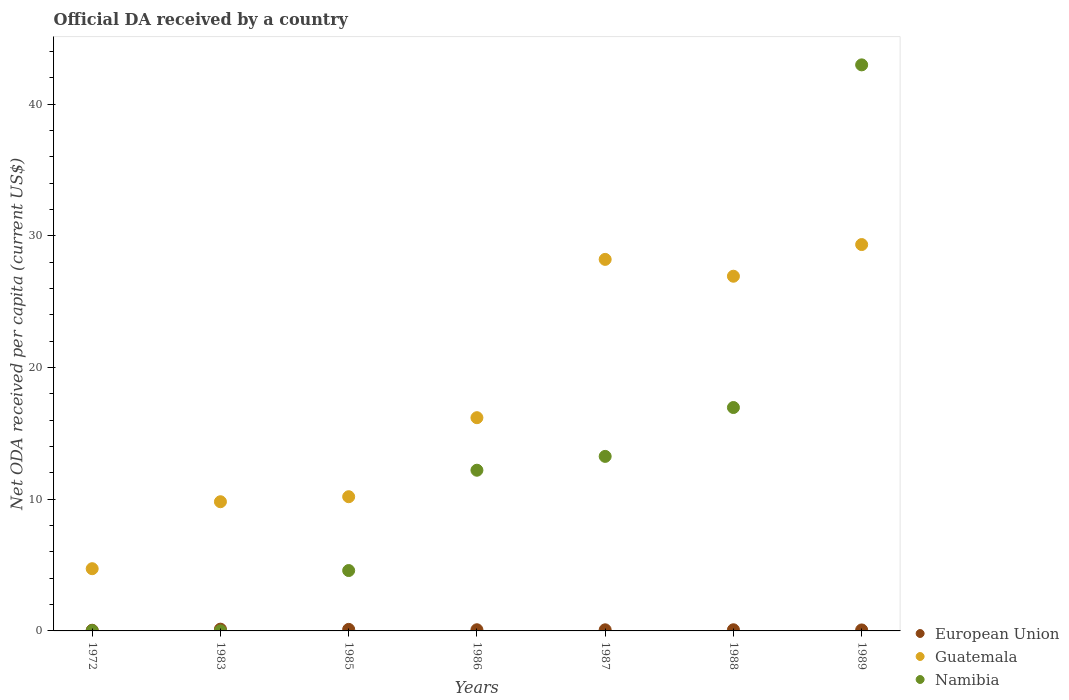How many different coloured dotlines are there?
Your answer should be compact. 3. Is the number of dotlines equal to the number of legend labels?
Offer a very short reply. Yes. What is the ODA received in in Guatemala in 1989?
Your answer should be very brief. 29.34. Across all years, what is the maximum ODA received in in Namibia?
Ensure brevity in your answer.  42.99. Across all years, what is the minimum ODA received in in Namibia?
Keep it short and to the point. 0.01. In which year was the ODA received in in Namibia minimum?
Your response must be concise. 1983. What is the total ODA received in in Namibia in the graph?
Offer a very short reply. 90.03. What is the difference between the ODA received in in Guatemala in 1985 and that in 1988?
Make the answer very short. -16.74. What is the difference between the ODA received in in European Union in 1986 and the ODA received in in Guatemala in 1987?
Offer a terse response. -28.13. What is the average ODA received in in Namibia per year?
Offer a terse response. 12.86. In the year 1985, what is the difference between the ODA received in in Guatemala and ODA received in in European Union?
Your answer should be very brief. 10.07. What is the ratio of the ODA received in in Guatemala in 1986 to that in 1989?
Your answer should be compact. 0.55. Is the ODA received in in Namibia in 1986 less than that in 1988?
Ensure brevity in your answer.  Yes. What is the difference between the highest and the second highest ODA received in in Guatemala?
Offer a very short reply. 1.13. What is the difference between the highest and the lowest ODA received in in Namibia?
Provide a succinct answer. 42.98. In how many years, is the ODA received in in European Union greater than the average ODA received in in European Union taken over all years?
Ensure brevity in your answer.  2. Is the sum of the ODA received in in Guatemala in 1986 and 1989 greater than the maximum ODA received in in Namibia across all years?
Make the answer very short. Yes. Does the ODA received in in Guatemala monotonically increase over the years?
Your answer should be compact. No. Is the ODA received in in Guatemala strictly greater than the ODA received in in Namibia over the years?
Provide a short and direct response. No. What is the difference between two consecutive major ticks on the Y-axis?
Give a very brief answer. 10. How are the legend labels stacked?
Provide a succinct answer. Vertical. What is the title of the graph?
Your answer should be compact. Official DA received by a country. What is the label or title of the Y-axis?
Ensure brevity in your answer.  Net ODA received per capita (current US$). What is the Net ODA received per capita (current US$) of European Union in 1972?
Keep it short and to the point. 0.05. What is the Net ODA received per capita (current US$) of Guatemala in 1972?
Provide a short and direct response. 4.72. What is the Net ODA received per capita (current US$) in Namibia in 1972?
Offer a terse response. 0.02. What is the Net ODA received per capita (current US$) in European Union in 1983?
Provide a short and direct response. 0.13. What is the Net ODA received per capita (current US$) in Guatemala in 1983?
Make the answer very short. 9.81. What is the Net ODA received per capita (current US$) in Namibia in 1983?
Your answer should be very brief. 0.01. What is the Net ODA received per capita (current US$) of European Union in 1985?
Your answer should be very brief. 0.12. What is the Net ODA received per capita (current US$) of Guatemala in 1985?
Your response must be concise. 10.19. What is the Net ODA received per capita (current US$) in Namibia in 1985?
Offer a terse response. 4.59. What is the Net ODA received per capita (current US$) in European Union in 1986?
Your answer should be very brief. 0.09. What is the Net ODA received per capita (current US$) of Guatemala in 1986?
Your answer should be compact. 16.19. What is the Net ODA received per capita (current US$) of Namibia in 1986?
Offer a very short reply. 12.2. What is the Net ODA received per capita (current US$) in European Union in 1987?
Offer a terse response. 0.08. What is the Net ODA received per capita (current US$) of Guatemala in 1987?
Your response must be concise. 28.21. What is the Net ODA received per capita (current US$) in Namibia in 1987?
Give a very brief answer. 13.25. What is the Net ODA received per capita (current US$) in European Union in 1988?
Make the answer very short. 0.09. What is the Net ODA received per capita (current US$) of Guatemala in 1988?
Keep it short and to the point. 26.94. What is the Net ODA received per capita (current US$) of Namibia in 1988?
Your answer should be very brief. 16.96. What is the Net ODA received per capita (current US$) of European Union in 1989?
Make the answer very short. 0.07. What is the Net ODA received per capita (current US$) in Guatemala in 1989?
Your response must be concise. 29.34. What is the Net ODA received per capita (current US$) in Namibia in 1989?
Your answer should be very brief. 42.99. Across all years, what is the maximum Net ODA received per capita (current US$) of European Union?
Ensure brevity in your answer.  0.13. Across all years, what is the maximum Net ODA received per capita (current US$) of Guatemala?
Ensure brevity in your answer.  29.34. Across all years, what is the maximum Net ODA received per capita (current US$) in Namibia?
Offer a terse response. 42.99. Across all years, what is the minimum Net ODA received per capita (current US$) of European Union?
Provide a succinct answer. 0.05. Across all years, what is the minimum Net ODA received per capita (current US$) in Guatemala?
Make the answer very short. 4.72. Across all years, what is the minimum Net ODA received per capita (current US$) in Namibia?
Offer a very short reply. 0.01. What is the total Net ODA received per capita (current US$) in European Union in the graph?
Your answer should be compact. 0.64. What is the total Net ODA received per capita (current US$) in Guatemala in the graph?
Your response must be concise. 125.41. What is the total Net ODA received per capita (current US$) of Namibia in the graph?
Your answer should be compact. 90.03. What is the difference between the Net ODA received per capita (current US$) in European Union in 1972 and that in 1983?
Provide a short and direct response. -0.08. What is the difference between the Net ODA received per capita (current US$) in Guatemala in 1972 and that in 1983?
Your response must be concise. -5.09. What is the difference between the Net ODA received per capita (current US$) in Namibia in 1972 and that in 1983?
Make the answer very short. 0.01. What is the difference between the Net ODA received per capita (current US$) in European Union in 1972 and that in 1985?
Offer a very short reply. -0.07. What is the difference between the Net ODA received per capita (current US$) in Guatemala in 1972 and that in 1985?
Make the answer very short. -5.47. What is the difference between the Net ODA received per capita (current US$) of Namibia in 1972 and that in 1985?
Make the answer very short. -4.56. What is the difference between the Net ODA received per capita (current US$) in European Union in 1972 and that in 1986?
Make the answer very short. -0.04. What is the difference between the Net ODA received per capita (current US$) of Guatemala in 1972 and that in 1986?
Make the answer very short. -11.47. What is the difference between the Net ODA received per capita (current US$) in Namibia in 1972 and that in 1986?
Make the answer very short. -12.18. What is the difference between the Net ODA received per capita (current US$) in European Union in 1972 and that in 1987?
Keep it short and to the point. -0.03. What is the difference between the Net ODA received per capita (current US$) of Guatemala in 1972 and that in 1987?
Offer a terse response. -23.49. What is the difference between the Net ODA received per capita (current US$) in Namibia in 1972 and that in 1987?
Provide a short and direct response. -13.23. What is the difference between the Net ODA received per capita (current US$) of European Union in 1972 and that in 1988?
Make the answer very short. -0.04. What is the difference between the Net ODA received per capita (current US$) in Guatemala in 1972 and that in 1988?
Your answer should be compact. -22.21. What is the difference between the Net ODA received per capita (current US$) of Namibia in 1972 and that in 1988?
Provide a succinct answer. -16.94. What is the difference between the Net ODA received per capita (current US$) of European Union in 1972 and that in 1989?
Keep it short and to the point. -0.02. What is the difference between the Net ODA received per capita (current US$) in Guatemala in 1972 and that in 1989?
Your response must be concise. -24.62. What is the difference between the Net ODA received per capita (current US$) in Namibia in 1972 and that in 1989?
Your answer should be compact. -42.96. What is the difference between the Net ODA received per capita (current US$) in European Union in 1983 and that in 1985?
Keep it short and to the point. 0.02. What is the difference between the Net ODA received per capita (current US$) of Guatemala in 1983 and that in 1985?
Keep it short and to the point. -0.38. What is the difference between the Net ODA received per capita (current US$) in Namibia in 1983 and that in 1985?
Your response must be concise. -4.58. What is the difference between the Net ODA received per capita (current US$) of European Union in 1983 and that in 1986?
Offer a very short reply. 0.04. What is the difference between the Net ODA received per capita (current US$) of Guatemala in 1983 and that in 1986?
Offer a very short reply. -6.38. What is the difference between the Net ODA received per capita (current US$) of Namibia in 1983 and that in 1986?
Keep it short and to the point. -12.19. What is the difference between the Net ODA received per capita (current US$) in European Union in 1983 and that in 1987?
Offer a terse response. 0.05. What is the difference between the Net ODA received per capita (current US$) of Guatemala in 1983 and that in 1987?
Provide a short and direct response. -18.4. What is the difference between the Net ODA received per capita (current US$) of Namibia in 1983 and that in 1987?
Your answer should be compact. -13.24. What is the difference between the Net ODA received per capita (current US$) of European Union in 1983 and that in 1988?
Provide a short and direct response. 0.05. What is the difference between the Net ODA received per capita (current US$) of Guatemala in 1983 and that in 1988?
Ensure brevity in your answer.  -17.12. What is the difference between the Net ODA received per capita (current US$) of Namibia in 1983 and that in 1988?
Keep it short and to the point. -16.96. What is the difference between the Net ODA received per capita (current US$) of European Union in 1983 and that in 1989?
Your answer should be very brief. 0.06. What is the difference between the Net ODA received per capita (current US$) of Guatemala in 1983 and that in 1989?
Offer a terse response. -19.53. What is the difference between the Net ODA received per capita (current US$) in Namibia in 1983 and that in 1989?
Your answer should be very brief. -42.98. What is the difference between the Net ODA received per capita (current US$) in European Union in 1985 and that in 1986?
Offer a terse response. 0.03. What is the difference between the Net ODA received per capita (current US$) in Guatemala in 1985 and that in 1986?
Your answer should be very brief. -6. What is the difference between the Net ODA received per capita (current US$) in Namibia in 1985 and that in 1986?
Make the answer very short. -7.62. What is the difference between the Net ODA received per capita (current US$) in European Union in 1985 and that in 1987?
Provide a short and direct response. 0.03. What is the difference between the Net ODA received per capita (current US$) of Guatemala in 1985 and that in 1987?
Ensure brevity in your answer.  -18.02. What is the difference between the Net ODA received per capita (current US$) of Namibia in 1985 and that in 1987?
Provide a short and direct response. -8.67. What is the difference between the Net ODA received per capita (current US$) of European Union in 1985 and that in 1988?
Your answer should be compact. 0.03. What is the difference between the Net ODA received per capita (current US$) in Guatemala in 1985 and that in 1988?
Provide a short and direct response. -16.74. What is the difference between the Net ODA received per capita (current US$) in Namibia in 1985 and that in 1988?
Keep it short and to the point. -12.38. What is the difference between the Net ODA received per capita (current US$) in European Union in 1985 and that in 1989?
Your answer should be compact. 0.04. What is the difference between the Net ODA received per capita (current US$) of Guatemala in 1985 and that in 1989?
Offer a very short reply. -19.15. What is the difference between the Net ODA received per capita (current US$) of Namibia in 1985 and that in 1989?
Make the answer very short. -38.4. What is the difference between the Net ODA received per capita (current US$) in European Union in 1986 and that in 1987?
Offer a terse response. 0. What is the difference between the Net ODA received per capita (current US$) of Guatemala in 1986 and that in 1987?
Offer a terse response. -12.02. What is the difference between the Net ODA received per capita (current US$) in Namibia in 1986 and that in 1987?
Keep it short and to the point. -1.05. What is the difference between the Net ODA received per capita (current US$) of European Union in 1986 and that in 1988?
Provide a short and direct response. 0. What is the difference between the Net ODA received per capita (current US$) in Guatemala in 1986 and that in 1988?
Offer a terse response. -10.74. What is the difference between the Net ODA received per capita (current US$) in Namibia in 1986 and that in 1988?
Your answer should be very brief. -4.76. What is the difference between the Net ODA received per capita (current US$) in European Union in 1986 and that in 1989?
Your answer should be very brief. 0.01. What is the difference between the Net ODA received per capita (current US$) in Guatemala in 1986 and that in 1989?
Your response must be concise. -13.15. What is the difference between the Net ODA received per capita (current US$) in Namibia in 1986 and that in 1989?
Provide a short and direct response. -30.78. What is the difference between the Net ODA received per capita (current US$) in European Union in 1987 and that in 1988?
Your answer should be compact. -0. What is the difference between the Net ODA received per capita (current US$) of Guatemala in 1987 and that in 1988?
Your response must be concise. 1.28. What is the difference between the Net ODA received per capita (current US$) in Namibia in 1987 and that in 1988?
Your response must be concise. -3.71. What is the difference between the Net ODA received per capita (current US$) of European Union in 1987 and that in 1989?
Ensure brevity in your answer.  0.01. What is the difference between the Net ODA received per capita (current US$) in Guatemala in 1987 and that in 1989?
Provide a short and direct response. -1.13. What is the difference between the Net ODA received per capita (current US$) in Namibia in 1987 and that in 1989?
Your answer should be very brief. -29.73. What is the difference between the Net ODA received per capita (current US$) in European Union in 1988 and that in 1989?
Keep it short and to the point. 0.01. What is the difference between the Net ODA received per capita (current US$) of Guatemala in 1988 and that in 1989?
Make the answer very short. -2.4. What is the difference between the Net ODA received per capita (current US$) of Namibia in 1988 and that in 1989?
Your answer should be very brief. -26.02. What is the difference between the Net ODA received per capita (current US$) in European Union in 1972 and the Net ODA received per capita (current US$) in Guatemala in 1983?
Your answer should be compact. -9.76. What is the difference between the Net ODA received per capita (current US$) in European Union in 1972 and the Net ODA received per capita (current US$) in Namibia in 1983?
Provide a succinct answer. 0.04. What is the difference between the Net ODA received per capita (current US$) in Guatemala in 1972 and the Net ODA received per capita (current US$) in Namibia in 1983?
Provide a short and direct response. 4.72. What is the difference between the Net ODA received per capita (current US$) of European Union in 1972 and the Net ODA received per capita (current US$) of Guatemala in 1985?
Provide a succinct answer. -10.14. What is the difference between the Net ODA received per capita (current US$) of European Union in 1972 and the Net ODA received per capita (current US$) of Namibia in 1985?
Your answer should be very brief. -4.54. What is the difference between the Net ODA received per capita (current US$) in Guatemala in 1972 and the Net ODA received per capita (current US$) in Namibia in 1985?
Give a very brief answer. 0.14. What is the difference between the Net ODA received per capita (current US$) of European Union in 1972 and the Net ODA received per capita (current US$) of Guatemala in 1986?
Provide a short and direct response. -16.14. What is the difference between the Net ODA received per capita (current US$) in European Union in 1972 and the Net ODA received per capita (current US$) in Namibia in 1986?
Provide a succinct answer. -12.15. What is the difference between the Net ODA received per capita (current US$) in Guatemala in 1972 and the Net ODA received per capita (current US$) in Namibia in 1986?
Ensure brevity in your answer.  -7.48. What is the difference between the Net ODA received per capita (current US$) of European Union in 1972 and the Net ODA received per capita (current US$) of Guatemala in 1987?
Your answer should be very brief. -28.16. What is the difference between the Net ODA received per capita (current US$) of European Union in 1972 and the Net ODA received per capita (current US$) of Namibia in 1987?
Your answer should be very brief. -13.2. What is the difference between the Net ODA received per capita (current US$) in Guatemala in 1972 and the Net ODA received per capita (current US$) in Namibia in 1987?
Your answer should be compact. -8.53. What is the difference between the Net ODA received per capita (current US$) of European Union in 1972 and the Net ODA received per capita (current US$) of Guatemala in 1988?
Your answer should be compact. -26.89. What is the difference between the Net ODA received per capita (current US$) in European Union in 1972 and the Net ODA received per capita (current US$) in Namibia in 1988?
Offer a terse response. -16.91. What is the difference between the Net ODA received per capita (current US$) in Guatemala in 1972 and the Net ODA received per capita (current US$) in Namibia in 1988?
Provide a short and direct response. -12.24. What is the difference between the Net ODA received per capita (current US$) of European Union in 1972 and the Net ODA received per capita (current US$) of Guatemala in 1989?
Give a very brief answer. -29.29. What is the difference between the Net ODA received per capita (current US$) in European Union in 1972 and the Net ODA received per capita (current US$) in Namibia in 1989?
Make the answer very short. -42.94. What is the difference between the Net ODA received per capita (current US$) in Guatemala in 1972 and the Net ODA received per capita (current US$) in Namibia in 1989?
Keep it short and to the point. -38.26. What is the difference between the Net ODA received per capita (current US$) of European Union in 1983 and the Net ODA received per capita (current US$) of Guatemala in 1985?
Offer a terse response. -10.06. What is the difference between the Net ODA received per capita (current US$) in European Union in 1983 and the Net ODA received per capita (current US$) in Namibia in 1985?
Offer a terse response. -4.45. What is the difference between the Net ODA received per capita (current US$) in Guatemala in 1983 and the Net ODA received per capita (current US$) in Namibia in 1985?
Keep it short and to the point. 5.23. What is the difference between the Net ODA received per capita (current US$) of European Union in 1983 and the Net ODA received per capita (current US$) of Guatemala in 1986?
Your response must be concise. -16.06. What is the difference between the Net ODA received per capita (current US$) in European Union in 1983 and the Net ODA received per capita (current US$) in Namibia in 1986?
Your answer should be compact. -12.07. What is the difference between the Net ODA received per capita (current US$) in Guatemala in 1983 and the Net ODA received per capita (current US$) in Namibia in 1986?
Give a very brief answer. -2.39. What is the difference between the Net ODA received per capita (current US$) in European Union in 1983 and the Net ODA received per capita (current US$) in Guatemala in 1987?
Provide a short and direct response. -28.08. What is the difference between the Net ODA received per capita (current US$) in European Union in 1983 and the Net ODA received per capita (current US$) in Namibia in 1987?
Ensure brevity in your answer.  -13.12. What is the difference between the Net ODA received per capita (current US$) of Guatemala in 1983 and the Net ODA received per capita (current US$) of Namibia in 1987?
Provide a short and direct response. -3.44. What is the difference between the Net ODA received per capita (current US$) in European Union in 1983 and the Net ODA received per capita (current US$) in Guatemala in 1988?
Make the answer very short. -26.8. What is the difference between the Net ODA received per capita (current US$) in European Union in 1983 and the Net ODA received per capita (current US$) in Namibia in 1988?
Your answer should be compact. -16.83. What is the difference between the Net ODA received per capita (current US$) of Guatemala in 1983 and the Net ODA received per capita (current US$) of Namibia in 1988?
Keep it short and to the point. -7.15. What is the difference between the Net ODA received per capita (current US$) of European Union in 1983 and the Net ODA received per capita (current US$) of Guatemala in 1989?
Keep it short and to the point. -29.21. What is the difference between the Net ODA received per capita (current US$) in European Union in 1983 and the Net ODA received per capita (current US$) in Namibia in 1989?
Offer a terse response. -42.85. What is the difference between the Net ODA received per capita (current US$) in Guatemala in 1983 and the Net ODA received per capita (current US$) in Namibia in 1989?
Offer a terse response. -33.18. What is the difference between the Net ODA received per capita (current US$) of European Union in 1985 and the Net ODA received per capita (current US$) of Guatemala in 1986?
Offer a terse response. -16.08. What is the difference between the Net ODA received per capita (current US$) in European Union in 1985 and the Net ODA received per capita (current US$) in Namibia in 1986?
Provide a succinct answer. -12.09. What is the difference between the Net ODA received per capita (current US$) of Guatemala in 1985 and the Net ODA received per capita (current US$) of Namibia in 1986?
Provide a succinct answer. -2.01. What is the difference between the Net ODA received per capita (current US$) in European Union in 1985 and the Net ODA received per capita (current US$) in Guatemala in 1987?
Offer a terse response. -28.1. What is the difference between the Net ODA received per capita (current US$) in European Union in 1985 and the Net ODA received per capita (current US$) in Namibia in 1987?
Provide a succinct answer. -13.14. What is the difference between the Net ODA received per capita (current US$) of Guatemala in 1985 and the Net ODA received per capita (current US$) of Namibia in 1987?
Ensure brevity in your answer.  -3.06. What is the difference between the Net ODA received per capita (current US$) of European Union in 1985 and the Net ODA received per capita (current US$) of Guatemala in 1988?
Give a very brief answer. -26.82. What is the difference between the Net ODA received per capita (current US$) of European Union in 1985 and the Net ODA received per capita (current US$) of Namibia in 1988?
Give a very brief answer. -16.85. What is the difference between the Net ODA received per capita (current US$) of Guatemala in 1985 and the Net ODA received per capita (current US$) of Namibia in 1988?
Ensure brevity in your answer.  -6.77. What is the difference between the Net ODA received per capita (current US$) in European Union in 1985 and the Net ODA received per capita (current US$) in Guatemala in 1989?
Give a very brief answer. -29.22. What is the difference between the Net ODA received per capita (current US$) in European Union in 1985 and the Net ODA received per capita (current US$) in Namibia in 1989?
Offer a terse response. -42.87. What is the difference between the Net ODA received per capita (current US$) of Guatemala in 1985 and the Net ODA received per capita (current US$) of Namibia in 1989?
Offer a very short reply. -32.79. What is the difference between the Net ODA received per capita (current US$) in European Union in 1986 and the Net ODA received per capita (current US$) in Guatemala in 1987?
Make the answer very short. -28.13. What is the difference between the Net ODA received per capita (current US$) of European Union in 1986 and the Net ODA received per capita (current US$) of Namibia in 1987?
Provide a succinct answer. -13.17. What is the difference between the Net ODA received per capita (current US$) of Guatemala in 1986 and the Net ODA received per capita (current US$) of Namibia in 1987?
Provide a short and direct response. 2.94. What is the difference between the Net ODA received per capita (current US$) in European Union in 1986 and the Net ODA received per capita (current US$) in Guatemala in 1988?
Ensure brevity in your answer.  -26.85. What is the difference between the Net ODA received per capita (current US$) in European Union in 1986 and the Net ODA received per capita (current US$) in Namibia in 1988?
Provide a succinct answer. -16.88. What is the difference between the Net ODA received per capita (current US$) in Guatemala in 1986 and the Net ODA received per capita (current US$) in Namibia in 1988?
Offer a terse response. -0.77. What is the difference between the Net ODA received per capita (current US$) of European Union in 1986 and the Net ODA received per capita (current US$) of Guatemala in 1989?
Give a very brief answer. -29.25. What is the difference between the Net ODA received per capita (current US$) in European Union in 1986 and the Net ODA received per capita (current US$) in Namibia in 1989?
Your answer should be compact. -42.9. What is the difference between the Net ODA received per capita (current US$) of Guatemala in 1986 and the Net ODA received per capita (current US$) of Namibia in 1989?
Keep it short and to the point. -26.79. What is the difference between the Net ODA received per capita (current US$) of European Union in 1987 and the Net ODA received per capita (current US$) of Guatemala in 1988?
Provide a short and direct response. -26.85. What is the difference between the Net ODA received per capita (current US$) in European Union in 1987 and the Net ODA received per capita (current US$) in Namibia in 1988?
Ensure brevity in your answer.  -16.88. What is the difference between the Net ODA received per capita (current US$) of Guatemala in 1987 and the Net ODA received per capita (current US$) of Namibia in 1988?
Your answer should be very brief. 11.25. What is the difference between the Net ODA received per capita (current US$) in European Union in 1987 and the Net ODA received per capita (current US$) in Guatemala in 1989?
Provide a succinct answer. -29.26. What is the difference between the Net ODA received per capita (current US$) in European Union in 1987 and the Net ODA received per capita (current US$) in Namibia in 1989?
Provide a succinct answer. -42.9. What is the difference between the Net ODA received per capita (current US$) in Guatemala in 1987 and the Net ODA received per capita (current US$) in Namibia in 1989?
Provide a short and direct response. -14.77. What is the difference between the Net ODA received per capita (current US$) of European Union in 1988 and the Net ODA received per capita (current US$) of Guatemala in 1989?
Make the answer very short. -29.25. What is the difference between the Net ODA received per capita (current US$) in European Union in 1988 and the Net ODA received per capita (current US$) in Namibia in 1989?
Your answer should be very brief. -42.9. What is the difference between the Net ODA received per capita (current US$) of Guatemala in 1988 and the Net ODA received per capita (current US$) of Namibia in 1989?
Your response must be concise. -16.05. What is the average Net ODA received per capita (current US$) of European Union per year?
Your response must be concise. 0.09. What is the average Net ODA received per capita (current US$) of Guatemala per year?
Make the answer very short. 17.92. What is the average Net ODA received per capita (current US$) in Namibia per year?
Ensure brevity in your answer.  12.86. In the year 1972, what is the difference between the Net ODA received per capita (current US$) in European Union and Net ODA received per capita (current US$) in Guatemala?
Ensure brevity in your answer.  -4.67. In the year 1972, what is the difference between the Net ODA received per capita (current US$) in European Union and Net ODA received per capita (current US$) in Namibia?
Offer a terse response. 0.03. In the year 1972, what is the difference between the Net ODA received per capita (current US$) in Guatemala and Net ODA received per capita (current US$) in Namibia?
Provide a short and direct response. 4.7. In the year 1983, what is the difference between the Net ODA received per capita (current US$) of European Union and Net ODA received per capita (current US$) of Guatemala?
Offer a terse response. -9.68. In the year 1983, what is the difference between the Net ODA received per capita (current US$) of European Union and Net ODA received per capita (current US$) of Namibia?
Ensure brevity in your answer.  0.12. In the year 1983, what is the difference between the Net ODA received per capita (current US$) of Guatemala and Net ODA received per capita (current US$) of Namibia?
Offer a terse response. 9.8. In the year 1985, what is the difference between the Net ODA received per capita (current US$) of European Union and Net ODA received per capita (current US$) of Guatemala?
Make the answer very short. -10.07. In the year 1985, what is the difference between the Net ODA received per capita (current US$) in European Union and Net ODA received per capita (current US$) in Namibia?
Provide a succinct answer. -4.47. In the year 1985, what is the difference between the Net ODA received per capita (current US$) in Guatemala and Net ODA received per capita (current US$) in Namibia?
Give a very brief answer. 5.61. In the year 1986, what is the difference between the Net ODA received per capita (current US$) of European Union and Net ODA received per capita (current US$) of Guatemala?
Ensure brevity in your answer.  -16.1. In the year 1986, what is the difference between the Net ODA received per capita (current US$) in European Union and Net ODA received per capita (current US$) in Namibia?
Your answer should be compact. -12.11. In the year 1986, what is the difference between the Net ODA received per capita (current US$) in Guatemala and Net ODA received per capita (current US$) in Namibia?
Make the answer very short. 3.99. In the year 1987, what is the difference between the Net ODA received per capita (current US$) in European Union and Net ODA received per capita (current US$) in Guatemala?
Your response must be concise. -28.13. In the year 1987, what is the difference between the Net ODA received per capita (current US$) in European Union and Net ODA received per capita (current US$) in Namibia?
Ensure brevity in your answer.  -13.17. In the year 1987, what is the difference between the Net ODA received per capita (current US$) of Guatemala and Net ODA received per capita (current US$) of Namibia?
Ensure brevity in your answer.  14.96. In the year 1988, what is the difference between the Net ODA received per capita (current US$) in European Union and Net ODA received per capita (current US$) in Guatemala?
Make the answer very short. -26.85. In the year 1988, what is the difference between the Net ODA received per capita (current US$) of European Union and Net ODA received per capita (current US$) of Namibia?
Offer a terse response. -16.88. In the year 1988, what is the difference between the Net ODA received per capita (current US$) in Guatemala and Net ODA received per capita (current US$) in Namibia?
Keep it short and to the point. 9.97. In the year 1989, what is the difference between the Net ODA received per capita (current US$) of European Union and Net ODA received per capita (current US$) of Guatemala?
Make the answer very short. -29.27. In the year 1989, what is the difference between the Net ODA received per capita (current US$) of European Union and Net ODA received per capita (current US$) of Namibia?
Make the answer very short. -42.91. In the year 1989, what is the difference between the Net ODA received per capita (current US$) of Guatemala and Net ODA received per capita (current US$) of Namibia?
Your answer should be very brief. -13.65. What is the ratio of the Net ODA received per capita (current US$) of European Union in 1972 to that in 1983?
Give a very brief answer. 0.37. What is the ratio of the Net ODA received per capita (current US$) in Guatemala in 1972 to that in 1983?
Ensure brevity in your answer.  0.48. What is the ratio of the Net ODA received per capita (current US$) of Namibia in 1972 to that in 1983?
Offer a very short reply. 2.61. What is the ratio of the Net ODA received per capita (current US$) in European Union in 1972 to that in 1985?
Provide a succinct answer. 0.43. What is the ratio of the Net ODA received per capita (current US$) in Guatemala in 1972 to that in 1985?
Your answer should be very brief. 0.46. What is the ratio of the Net ODA received per capita (current US$) of Namibia in 1972 to that in 1985?
Make the answer very short. 0.01. What is the ratio of the Net ODA received per capita (current US$) in European Union in 1972 to that in 1986?
Your answer should be compact. 0.56. What is the ratio of the Net ODA received per capita (current US$) of Guatemala in 1972 to that in 1986?
Ensure brevity in your answer.  0.29. What is the ratio of the Net ODA received per capita (current US$) of Namibia in 1972 to that in 1986?
Give a very brief answer. 0. What is the ratio of the Net ODA received per capita (current US$) of European Union in 1972 to that in 1987?
Your answer should be compact. 0.59. What is the ratio of the Net ODA received per capita (current US$) in Guatemala in 1972 to that in 1987?
Offer a terse response. 0.17. What is the ratio of the Net ODA received per capita (current US$) in Namibia in 1972 to that in 1987?
Your answer should be compact. 0. What is the ratio of the Net ODA received per capita (current US$) of European Union in 1972 to that in 1988?
Make the answer very short. 0.57. What is the ratio of the Net ODA received per capita (current US$) of Guatemala in 1972 to that in 1988?
Give a very brief answer. 0.18. What is the ratio of the Net ODA received per capita (current US$) of Namibia in 1972 to that in 1988?
Your answer should be compact. 0. What is the ratio of the Net ODA received per capita (current US$) of European Union in 1972 to that in 1989?
Make the answer very short. 0.67. What is the ratio of the Net ODA received per capita (current US$) in Guatemala in 1972 to that in 1989?
Offer a terse response. 0.16. What is the ratio of the Net ODA received per capita (current US$) of Namibia in 1972 to that in 1989?
Provide a succinct answer. 0. What is the ratio of the Net ODA received per capita (current US$) of European Union in 1983 to that in 1985?
Offer a terse response. 1.14. What is the ratio of the Net ODA received per capita (current US$) in Guatemala in 1983 to that in 1985?
Provide a short and direct response. 0.96. What is the ratio of the Net ODA received per capita (current US$) in Namibia in 1983 to that in 1985?
Ensure brevity in your answer.  0. What is the ratio of the Net ODA received per capita (current US$) of European Union in 1983 to that in 1986?
Provide a succinct answer. 1.51. What is the ratio of the Net ODA received per capita (current US$) of Guatemala in 1983 to that in 1986?
Keep it short and to the point. 0.61. What is the ratio of the Net ODA received per capita (current US$) of Namibia in 1983 to that in 1986?
Provide a short and direct response. 0. What is the ratio of the Net ODA received per capita (current US$) of European Union in 1983 to that in 1987?
Your response must be concise. 1.59. What is the ratio of the Net ODA received per capita (current US$) in Guatemala in 1983 to that in 1987?
Offer a terse response. 0.35. What is the ratio of the Net ODA received per capita (current US$) in Namibia in 1983 to that in 1987?
Give a very brief answer. 0. What is the ratio of the Net ODA received per capita (current US$) in European Union in 1983 to that in 1988?
Ensure brevity in your answer.  1.53. What is the ratio of the Net ODA received per capita (current US$) in Guatemala in 1983 to that in 1988?
Keep it short and to the point. 0.36. What is the ratio of the Net ODA received per capita (current US$) in European Union in 1983 to that in 1989?
Provide a succinct answer. 1.79. What is the ratio of the Net ODA received per capita (current US$) in Guatemala in 1983 to that in 1989?
Provide a succinct answer. 0.33. What is the ratio of the Net ODA received per capita (current US$) of Namibia in 1983 to that in 1989?
Give a very brief answer. 0. What is the ratio of the Net ODA received per capita (current US$) in European Union in 1985 to that in 1986?
Ensure brevity in your answer.  1.32. What is the ratio of the Net ODA received per capita (current US$) in Guatemala in 1985 to that in 1986?
Offer a terse response. 0.63. What is the ratio of the Net ODA received per capita (current US$) in Namibia in 1985 to that in 1986?
Your answer should be very brief. 0.38. What is the ratio of the Net ODA received per capita (current US$) of European Union in 1985 to that in 1987?
Your answer should be compact. 1.39. What is the ratio of the Net ODA received per capita (current US$) of Guatemala in 1985 to that in 1987?
Give a very brief answer. 0.36. What is the ratio of the Net ODA received per capita (current US$) in Namibia in 1985 to that in 1987?
Provide a succinct answer. 0.35. What is the ratio of the Net ODA received per capita (current US$) in European Union in 1985 to that in 1988?
Offer a very short reply. 1.35. What is the ratio of the Net ODA received per capita (current US$) in Guatemala in 1985 to that in 1988?
Provide a short and direct response. 0.38. What is the ratio of the Net ODA received per capita (current US$) of Namibia in 1985 to that in 1988?
Make the answer very short. 0.27. What is the ratio of the Net ODA received per capita (current US$) of European Union in 1985 to that in 1989?
Provide a succinct answer. 1.57. What is the ratio of the Net ODA received per capita (current US$) of Guatemala in 1985 to that in 1989?
Make the answer very short. 0.35. What is the ratio of the Net ODA received per capita (current US$) of Namibia in 1985 to that in 1989?
Provide a succinct answer. 0.11. What is the ratio of the Net ODA received per capita (current US$) of European Union in 1986 to that in 1987?
Make the answer very short. 1.05. What is the ratio of the Net ODA received per capita (current US$) of Guatemala in 1986 to that in 1987?
Provide a succinct answer. 0.57. What is the ratio of the Net ODA received per capita (current US$) of Namibia in 1986 to that in 1987?
Your answer should be compact. 0.92. What is the ratio of the Net ODA received per capita (current US$) of European Union in 1986 to that in 1988?
Ensure brevity in your answer.  1.02. What is the ratio of the Net ODA received per capita (current US$) of Guatemala in 1986 to that in 1988?
Offer a terse response. 0.6. What is the ratio of the Net ODA received per capita (current US$) of Namibia in 1986 to that in 1988?
Your response must be concise. 0.72. What is the ratio of the Net ODA received per capita (current US$) of European Union in 1986 to that in 1989?
Offer a terse response. 1.19. What is the ratio of the Net ODA received per capita (current US$) in Guatemala in 1986 to that in 1989?
Provide a short and direct response. 0.55. What is the ratio of the Net ODA received per capita (current US$) of Namibia in 1986 to that in 1989?
Make the answer very short. 0.28. What is the ratio of the Net ODA received per capita (current US$) of European Union in 1987 to that in 1988?
Offer a very short reply. 0.97. What is the ratio of the Net ODA received per capita (current US$) in Guatemala in 1987 to that in 1988?
Offer a very short reply. 1.05. What is the ratio of the Net ODA received per capita (current US$) of Namibia in 1987 to that in 1988?
Your response must be concise. 0.78. What is the ratio of the Net ODA received per capita (current US$) in European Union in 1987 to that in 1989?
Your answer should be very brief. 1.13. What is the ratio of the Net ODA received per capita (current US$) in Guatemala in 1987 to that in 1989?
Offer a very short reply. 0.96. What is the ratio of the Net ODA received per capita (current US$) of Namibia in 1987 to that in 1989?
Ensure brevity in your answer.  0.31. What is the ratio of the Net ODA received per capita (current US$) of European Union in 1988 to that in 1989?
Your response must be concise. 1.17. What is the ratio of the Net ODA received per capita (current US$) in Guatemala in 1988 to that in 1989?
Ensure brevity in your answer.  0.92. What is the ratio of the Net ODA received per capita (current US$) in Namibia in 1988 to that in 1989?
Your response must be concise. 0.39. What is the difference between the highest and the second highest Net ODA received per capita (current US$) of European Union?
Keep it short and to the point. 0.02. What is the difference between the highest and the second highest Net ODA received per capita (current US$) of Guatemala?
Your answer should be very brief. 1.13. What is the difference between the highest and the second highest Net ODA received per capita (current US$) of Namibia?
Give a very brief answer. 26.02. What is the difference between the highest and the lowest Net ODA received per capita (current US$) in European Union?
Offer a very short reply. 0.08. What is the difference between the highest and the lowest Net ODA received per capita (current US$) of Guatemala?
Your answer should be very brief. 24.62. What is the difference between the highest and the lowest Net ODA received per capita (current US$) in Namibia?
Give a very brief answer. 42.98. 